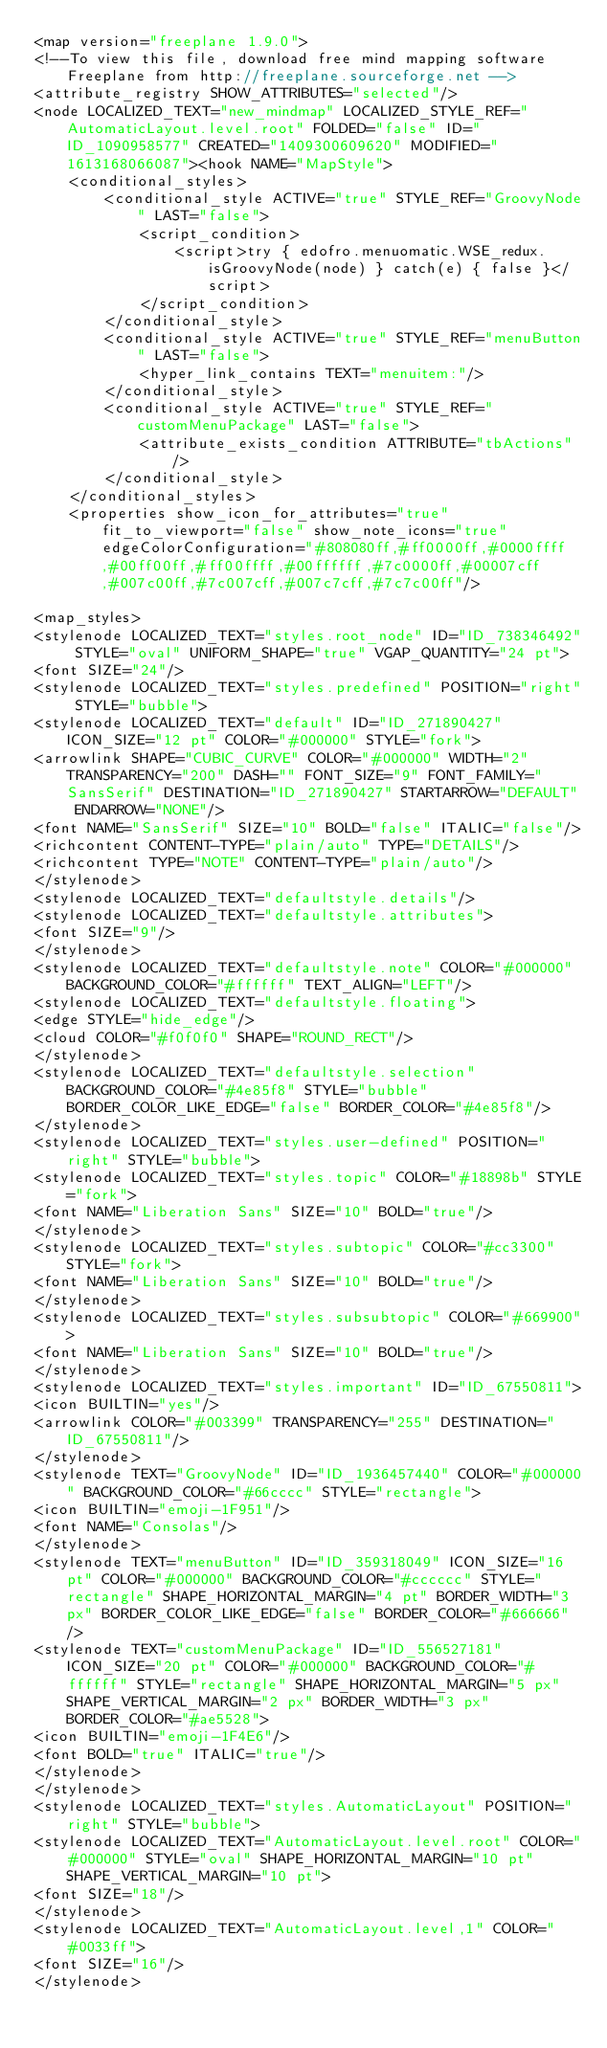Convert code to text. <code><loc_0><loc_0><loc_500><loc_500><_ObjectiveC_><map version="freeplane 1.9.0">
<!--To view this file, download free mind mapping software Freeplane from http://freeplane.sourceforge.net -->
<attribute_registry SHOW_ATTRIBUTES="selected"/>
<node LOCALIZED_TEXT="new_mindmap" LOCALIZED_STYLE_REF="AutomaticLayout.level.root" FOLDED="false" ID="ID_1090958577" CREATED="1409300609620" MODIFIED="1613168066087"><hook NAME="MapStyle">
    <conditional_styles>
        <conditional_style ACTIVE="true" STYLE_REF="GroovyNode" LAST="false">
            <script_condition>
                <script>try { edofro.menuomatic.WSE_redux.isGroovyNode(node) } catch(e) { false }</script>
            </script_condition>
        </conditional_style>
        <conditional_style ACTIVE="true" STYLE_REF="menuButton" LAST="false">
            <hyper_link_contains TEXT="menuitem:"/>
        </conditional_style>
        <conditional_style ACTIVE="true" STYLE_REF="customMenuPackage" LAST="false">
            <attribute_exists_condition ATTRIBUTE="tbActions"/>
        </conditional_style>
    </conditional_styles>
    <properties show_icon_for_attributes="true" fit_to_viewport="false" show_note_icons="true" edgeColorConfiguration="#808080ff,#ff0000ff,#0000ffff,#00ff00ff,#ff00ffff,#00ffffff,#7c0000ff,#00007cff,#007c00ff,#7c007cff,#007c7cff,#7c7c00ff"/>

<map_styles>
<stylenode LOCALIZED_TEXT="styles.root_node" ID="ID_738346492" STYLE="oval" UNIFORM_SHAPE="true" VGAP_QUANTITY="24 pt">
<font SIZE="24"/>
<stylenode LOCALIZED_TEXT="styles.predefined" POSITION="right" STYLE="bubble">
<stylenode LOCALIZED_TEXT="default" ID="ID_271890427" ICON_SIZE="12 pt" COLOR="#000000" STYLE="fork">
<arrowlink SHAPE="CUBIC_CURVE" COLOR="#000000" WIDTH="2" TRANSPARENCY="200" DASH="" FONT_SIZE="9" FONT_FAMILY="SansSerif" DESTINATION="ID_271890427" STARTARROW="DEFAULT" ENDARROW="NONE"/>
<font NAME="SansSerif" SIZE="10" BOLD="false" ITALIC="false"/>
<richcontent CONTENT-TYPE="plain/auto" TYPE="DETAILS"/>
<richcontent TYPE="NOTE" CONTENT-TYPE="plain/auto"/>
</stylenode>
<stylenode LOCALIZED_TEXT="defaultstyle.details"/>
<stylenode LOCALIZED_TEXT="defaultstyle.attributes">
<font SIZE="9"/>
</stylenode>
<stylenode LOCALIZED_TEXT="defaultstyle.note" COLOR="#000000" BACKGROUND_COLOR="#ffffff" TEXT_ALIGN="LEFT"/>
<stylenode LOCALIZED_TEXT="defaultstyle.floating">
<edge STYLE="hide_edge"/>
<cloud COLOR="#f0f0f0" SHAPE="ROUND_RECT"/>
</stylenode>
<stylenode LOCALIZED_TEXT="defaultstyle.selection" BACKGROUND_COLOR="#4e85f8" STYLE="bubble" BORDER_COLOR_LIKE_EDGE="false" BORDER_COLOR="#4e85f8"/>
</stylenode>
<stylenode LOCALIZED_TEXT="styles.user-defined" POSITION="right" STYLE="bubble">
<stylenode LOCALIZED_TEXT="styles.topic" COLOR="#18898b" STYLE="fork">
<font NAME="Liberation Sans" SIZE="10" BOLD="true"/>
</stylenode>
<stylenode LOCALIZED_TEXT="styles.subtopic" COLOR="#cc3300" STYLE="fork">
<font NAME="Liberation Sans" SIZE="10" BOLD="true"/>
</stylenode>
<stylenode LOCALIZED_TEXT="styles.subsubtopic" COLOR="#669900">
<font NAME="Liberation Sans" SIZE="10" BOLD="true"/>
</stylenode>
<stylenode LOCALIZED_TEXT="styles.important" ID="ID_67550811">
<icon BUILTIN="yes"/>
<arrowlink COLOR="#003399" TRANSPARENCY="255" DESTINATION="ID_67550811"/>
</stylenode>
<stylenode TEXT="GroovyNode" ID="ID_1936457440" COLOR="#000000" BACKGROUND_COLOR="#66cccc" STYLE="rectangle">
<icon BUILTIN="emoji-1F951"/>
<font NAME="Consolas"/>
</stylenode>
<stylenode TEXT="menuButton" ID="ID_359318049" ICON_SIZE="16 pt" COLOR="#000000" BACKGROUND_COLOR="#cccccc" STYLE="rectangle" SHAPE_HORIZONTAL_MARGIN="4 pt" BORDER_WIDTH="3 px" BORDER_COLOR_LIKE_EDGE="false" BORDER_COLOR="#666666"/>
<stylenode TEXT="customMenuPackage" ID="ID_556527181" ICON_SIZE="20 pt" COLOR="#000000" BACKGROUND_COLOR="#ffffff" STYLE="rectangle" SHAPE_HORIZONTAL_MARGIN="5 px" SHAPE_VERTICAL_MARGIN="2 px" BORDER_WIDTH="3 px" BORDER_COLOR="#ae5528">
<icon BUILTIN="emoji-1F4E6"/>
<font BOLD="true" ITALIC="true"/>
</stylenode>
</stylenode>
<stylenode LOCALIZED_TEXT="styles.AutomaticLayout" POSITION="right" STYLE="bubble">
<stylenode LOCALIZED_TEXT="AutomaticLayout.level.root" COLOR="#000000" STYLE="oval" SHAPE_HORIZONTAL_MARGIN="10 pt" SHAPE_VERTICAL_MARGIN="10 pt">
<font SIZE="18"/>
</stylenode>
<stylenode LOCALIZED_TEXT="AutomaticLayout.level,1" COLOR="#0033ff">
<font SIZE="16"/>
</stylenode></code> 